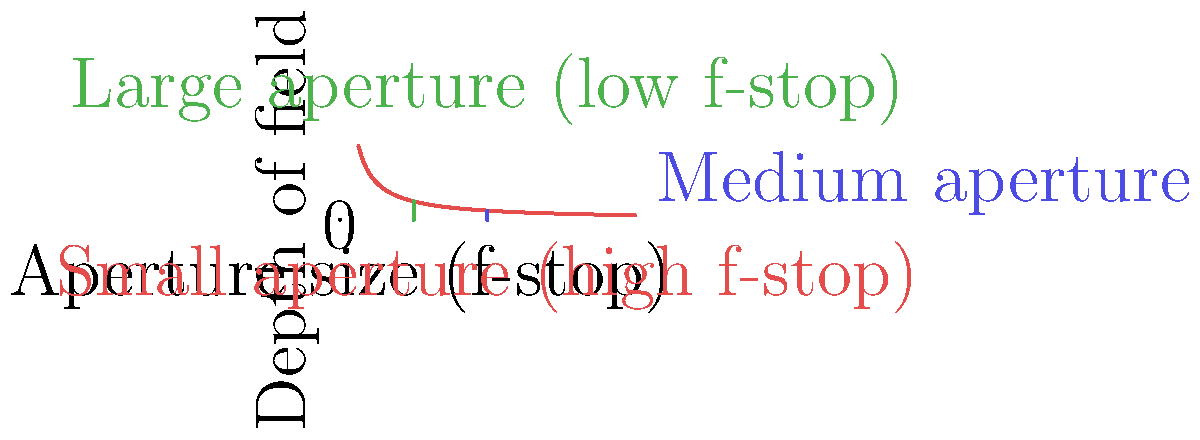When photographing vinyl records, how does changing the aperture size affect the depth of field, and why is this important for capturing the intricate details of record grooves? 1. Aperture size and depth of field relationship:
   - Aperture size is inversely proportional to depth of field.
   - Smaller apertures (higher f-stops) increase depth of field.
   - Larger apertures (lower f-stops) decrease depth of field.

2. Effect on vinyl record photography:
   - Vinyl records have grooves with varying depths and widths.
   - A larger depth of field allows more of the record's surface to be in focus.

3. Small aperture (high f-stop):
   - Increases depth of field.
   - More of the record's surface will be in sharp focus.
   - Allows for capturing more detail across the entire record surface.

4. Large aperture (low f-stop):
   - Decreases depth of field.
   - Only a narrow slice of the record's surface will be in sharp focus.
   - Can be used for artistic effect, highlighting specific areas of the record.

5. Importance for capturing record grooves:
   - Record grooves have depth, requiring sufficient depth of field to capture clearly.
   - Smaller apertures ensure more of the grooves are in focus, revealing intricate details.
   - This is crucial for showcasing the analog nature and texture of vinyl records.

6. Balancing factors:
   - Smaller apertures require longer exposure times or higher ISO settings.
   - Photographers must balance depth of field with other exposure parameters.

7. Artistic considerations:
   - Depth of field can be used creatively to draw attention to specific parts of the record.
   - Selective focus can emphasize certain aspects like labels or particular grooves.
Answer: Smaller apertures increase depth of field, allowing more of the record's surface and grooves to be in sharp focus, which is crucial for capturing intricate vinyl details. 